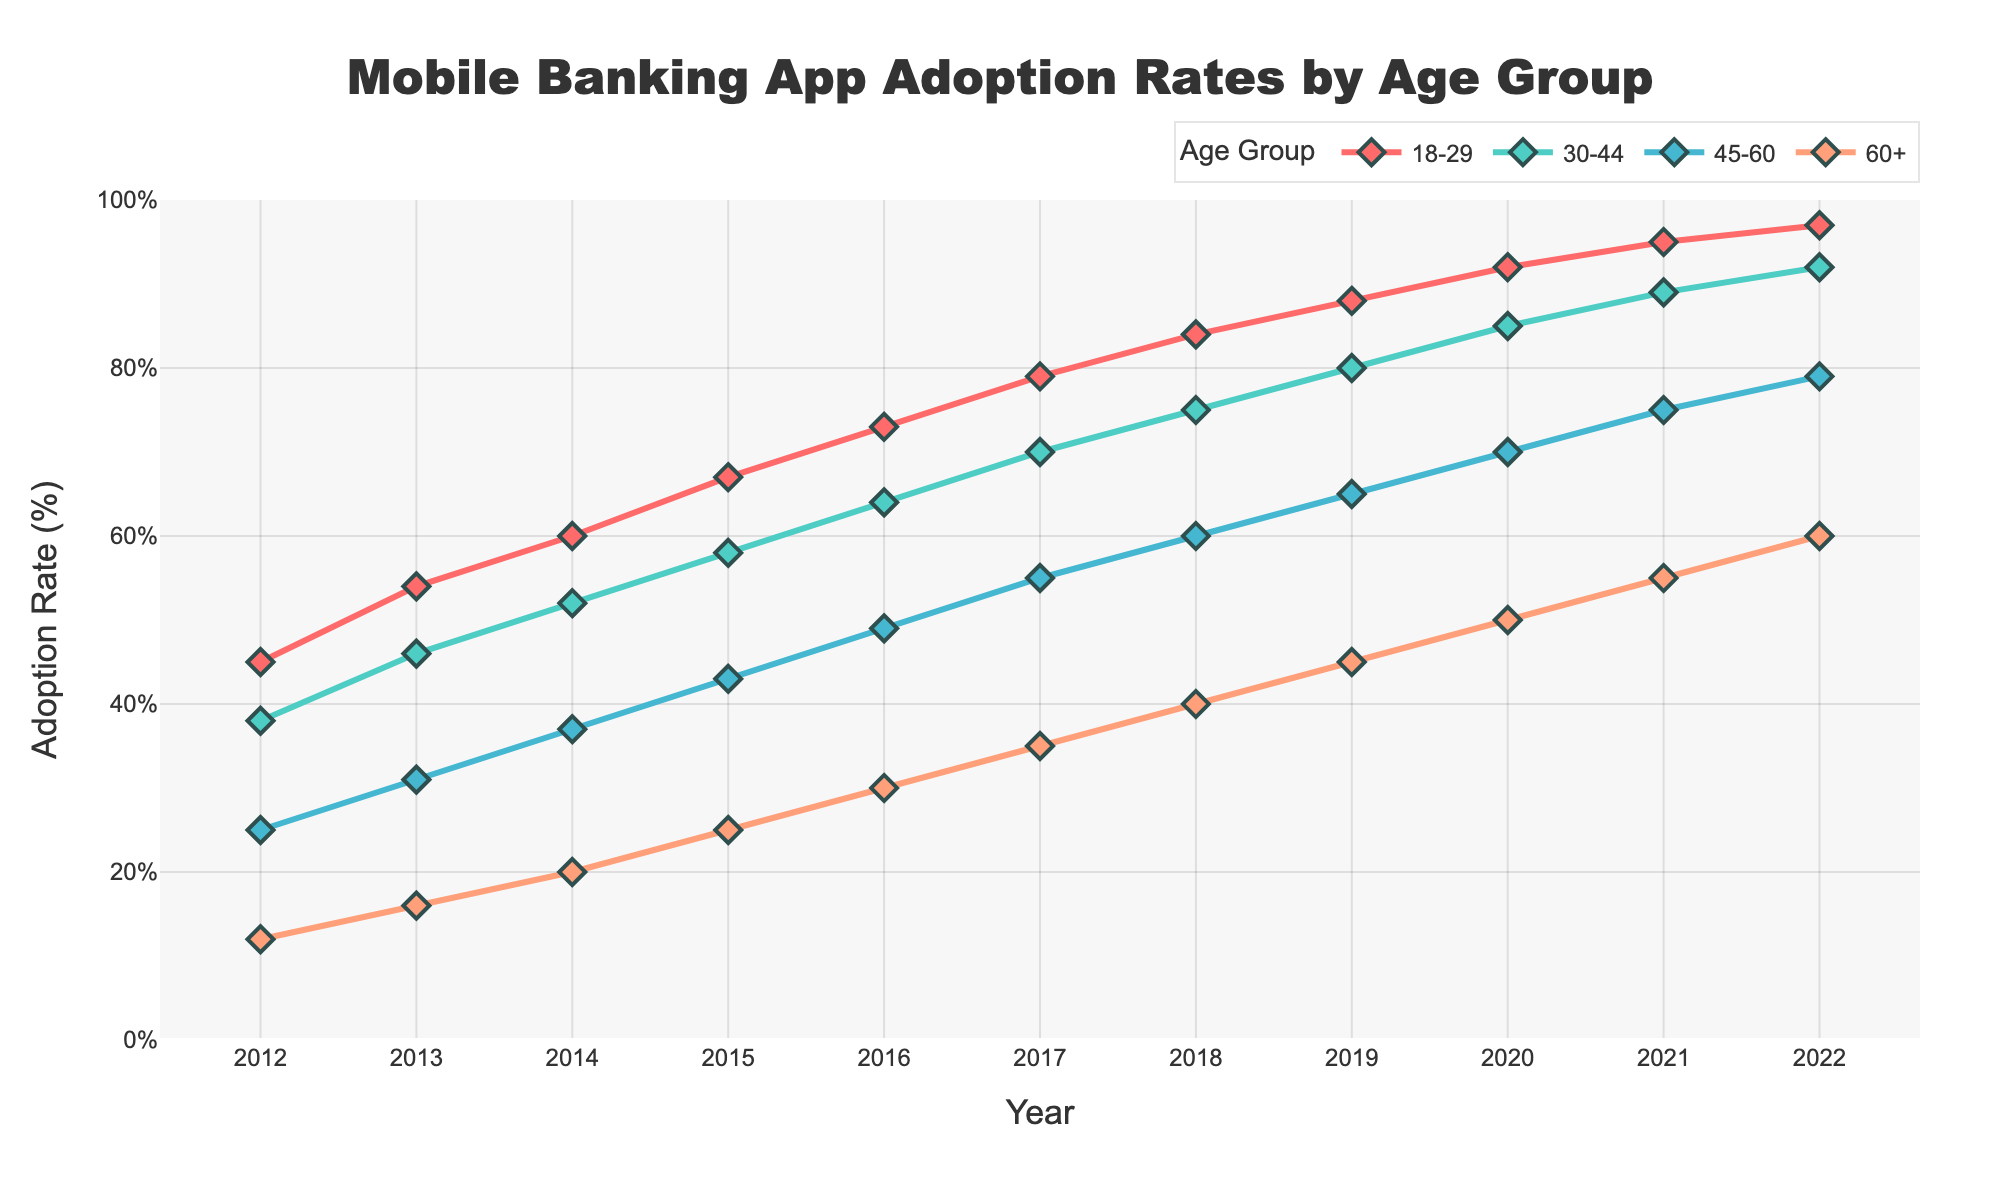What age group had the highest adoption rate in 2022? Look at the values for each age group in the year 2022; the group 18-29 has the highest value of 97%.
Answer: 18-29 How did the adoption rate change for the 30-44 age group from 2012 to 2022? Subtract the adoption rate of 30-44 in 2012 from its adoption rate in 2022, which is 92% - 38% = 54%.
Answer: Increased by 54% Which two age groups had the closest adoption rates in 2018? Compare the adoption rates of all age groups in 2018 and find the two closest values. The rates for 18-29 and 30-44 are 84% and 75%, respectively, which have the smallest difference of 9%.
Answer: 18-29 and 30-44 What's the average adoption rate for the 45-60 age group from 2012 to 2022? Sum the adoption rates of the 45-60 age group from 2012 to 2022 and divide by the number of years (11): (25 + 31 + 37 + 43 + 49 + 55 + 60 + 65 + 70 + 75 + 79) / 11 = 549 / 11 = 49.91%.
Answer: 49.91% Which age group experienced the highest increase in adoption rate from 2014 to 2015? Subtract the 2014 adoption rates from the 2015 rates for each age group and determine the one with the largest difference: 45-60 is 43% - 37% = 6%, which is the highest.
Answer: 45-60 Between which consecutive years did the 60+ age group see the largest increase in adoption rate? Calculate the yearly change for the 60+ group and find the largest difference between consecutive years: the largest increase was from 2019 (45%) to 2020 (50%), an increase of 5%.
Answer: 2019 to 2020 What is the trend in adoption rates for all age groups from 2012 to 2022? Observe that the lines for all age groups rise steadily over time, indicating a consistent increase in adoption rates.
Answer: Increasing trend Are the adoption rates in the 45-60 age group in 2016 and the 60+ age group in 2021 equal? Check the adoption rates in 2016 for 45-60 (49%) and in 2021 for 60+ (55%); they are not equal.
Answer: No How much higher was the adoption rate for the 18-29 age group compared to the 60+ age group in 2020? Subtract the adoption rate of the 60+ age group in 2020 from that of the 18-29 age group: 92% - 50% = 42%.
Answer: 42% higher In what year did the adoption rate for the 30-44 age group first exceed 50%? Check the values for the 30-44 group until you find the first year where the rate exceeds 50%; this happens in 2014 with 52%.
Answer: 2014 